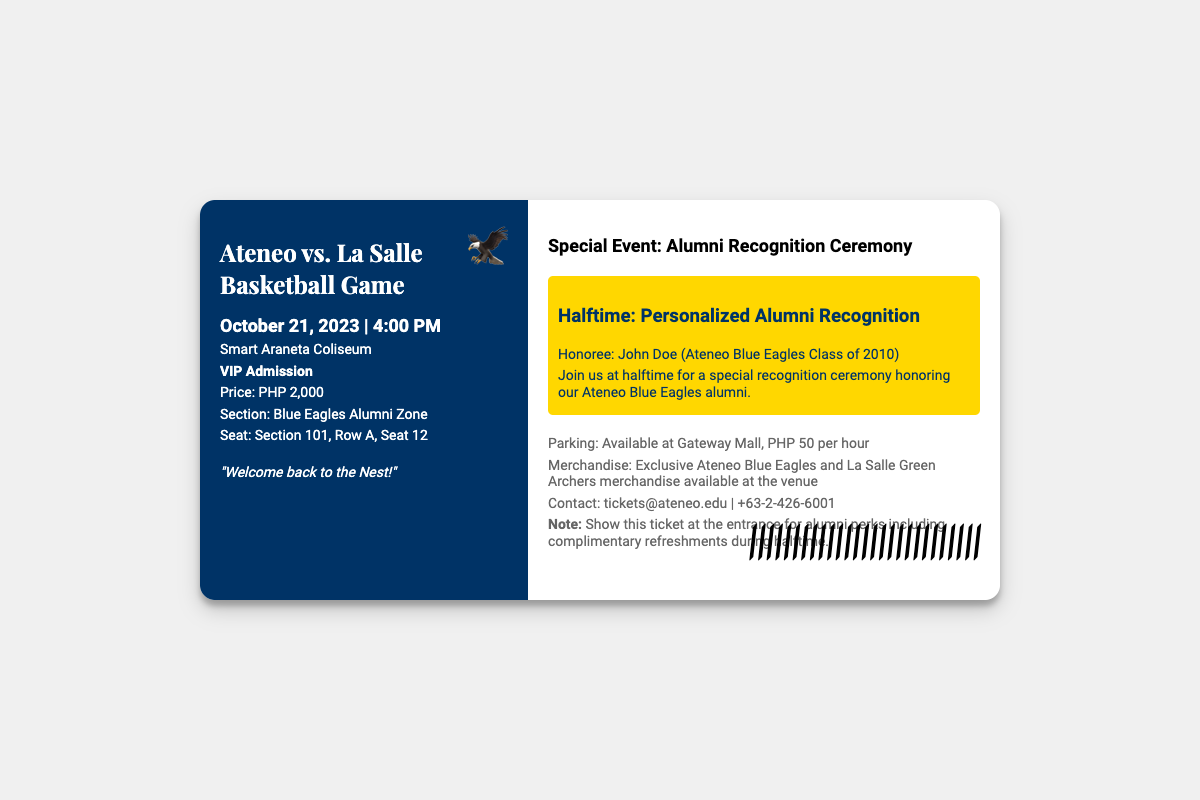What is the event date? The event date is specified in the document, which states "October 21, 2023".
Answer: October 21, 2023 What is the ticket price? The ticket price is clearly mentioned in the document as PHP 2,000.
Answer: PHP 2,000 What is the seat number? The document provides the seat information which states "Section 101, Row A, Seat 12".
Answer: Section 101, Row A, Seat 12 Who is being honored during halftime? The document lists the honoree as "John Doe (Ateneo Blue Eagles Class of 2010)".
Answer: John Doe Where is the game being held? The document mentions the location as "Smart Araneta Coliseum".
Answer: Smart Araneta Coliseum How much does parking cost? The document includes a parking cost of "PHP 50 per hour".
Answer: PHP 50 per hour What color is the ticket background? The document describes the ticket background color, which is "white".
Answer: white What special recognition event is listed? The document outlines a special event that is "Personalized Alumni Recognition".
Answer: Personalized Alumni Recognition What is the benefit mentioned for alumni during halftime? The document states that alumni perks include "complimentary refreshments during halftime".
Answer: complimentary refreshments during halftime 